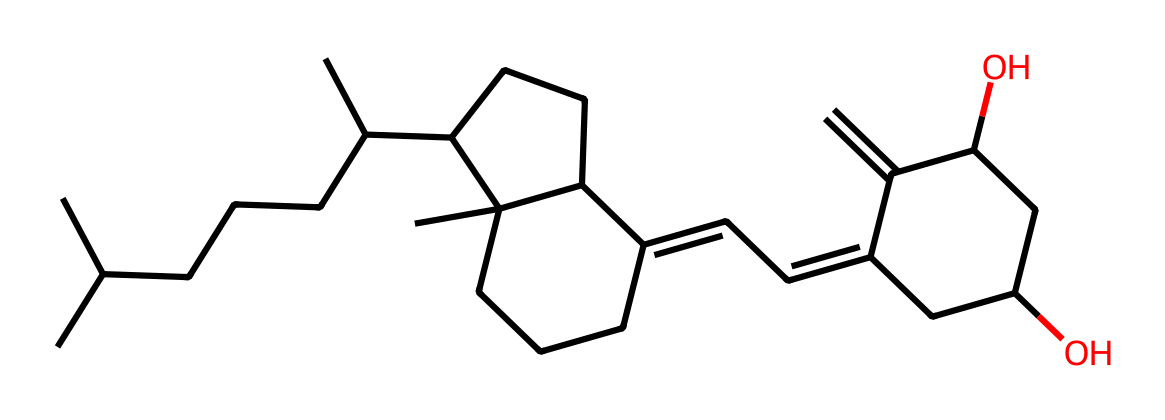What is the molecular formula of Vitamin D? The molecular formula can be deduced from the chemical structure by counting the number of carbon (C), hydrogen (H), and oxygen (O) atoms. In the given SMILES, there are 27 carbon atoms, 44 hydrogen atoms, and 2 oxygen atoms. Therefore, the molecular formula of Vitamin D is C27H44O2.
Answer: C27H44O2 How many rings are present in this Vitamin D structure? Upon analyzing the SMILES representation, we can identify that the structure contains three distinct cyclic (ring) components. Counting these rings indicates that there are three rings in total in the Vitamin D molecule.
Answer: 3 What type of vitamin is represented by this SMILES structure? The given structure corresponds to Vitamin D, a fat-soluble vitamin that plays a critical role in calcium metabolism and bone health. The distinct structural features observed in the molecule classify it as a vitamin.
Answer: Vitamin D What is the primary function of Vitamin D in public health? Vitamin D is essential for enhancing calcium absorption in the gut and maintaining adequate serum calcium and phosphate concentrations. This function is crucial for bone health and preventing diseases such as rickets and osteoporosis, thus influencing public health policies focused on nutrition and preventive care.
Answer: Calcium absorption How does the structure of Vitamin D relate to its solubility? The presence of multiple carbon chains and a small number of oxygen atoms in the structure relates to its lipophilicity, making Vitamin D a fat-soluble vitamin. The large hydrophobic (water-repelling) portion dominates, confirming its solubility in fats rather than water.
Answer: Fat-soluble 